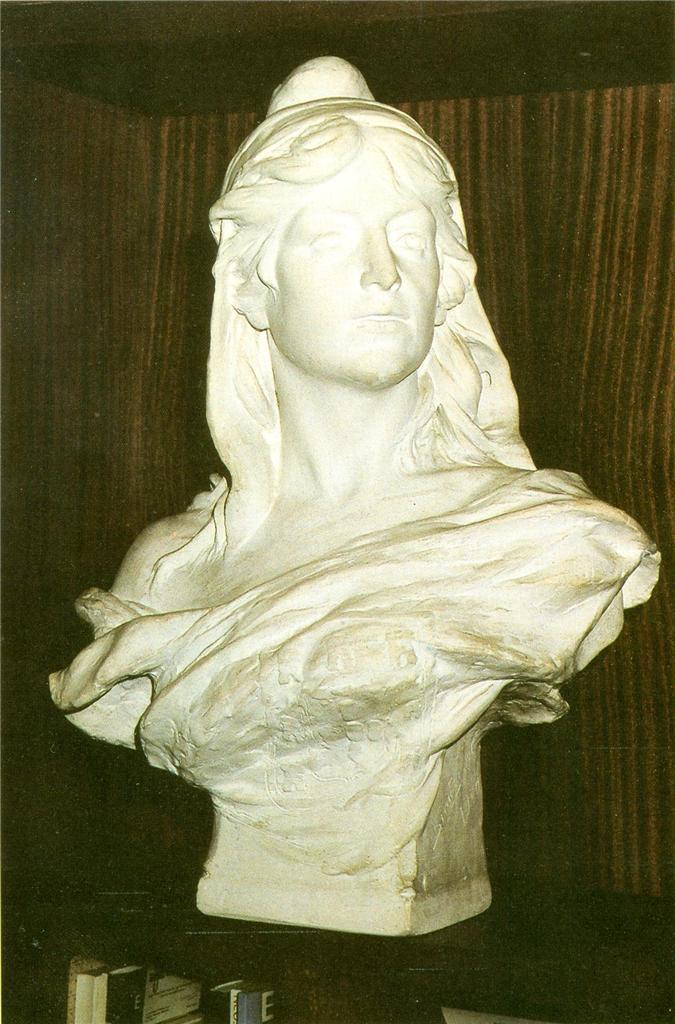Please provide a concise description of this image. In the center of the image, we can see a sculpture and in the background, there is a wall. 